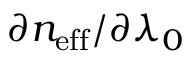<formula> <loc_0><loc_0><loc_500><loc_500>\partial n _ { e f f } / \partial \lambda _ { 0 }</formula> 